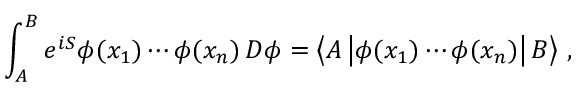<formula> <loc_0><loc_0><loc_500><loc_500>\int _ { A } ^ { B } e ^ { i S } \phi ( x _ { 1 } ) \cdots \phi ( x _ { n } ) \, D \phi = \left \langle A \left | \phi ( x _ { 1 } ) \cdots \phi ( x _ { n } ) \right | B \right \rangle \, ,</formula> 